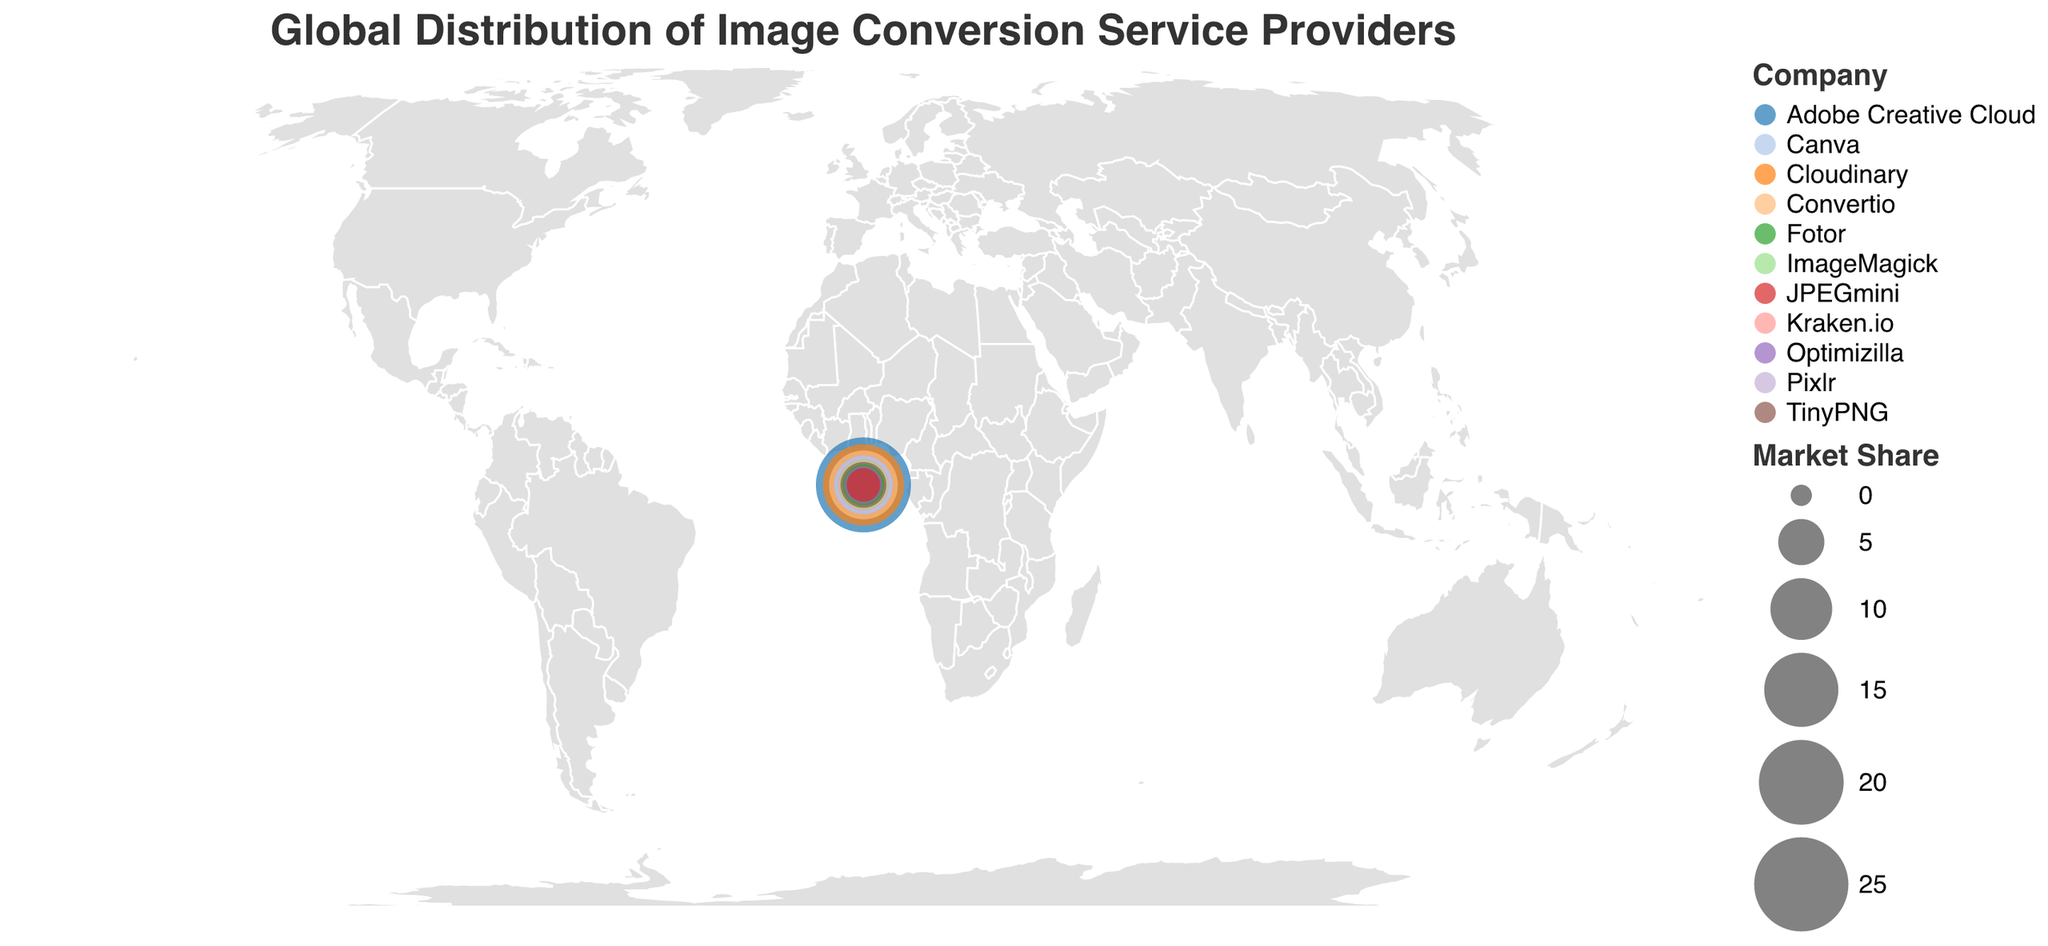What's the title of the figure? The title is typically located at the top of the figure and is displayed in a larger font size.
Answer: Global Distribution of Image Conversion Service Providers Which country has the highest market share in image conversion service providers? By examining the size of the circles, the country with the largest circle represents the highest market share.
Answer: United States What is the market share of Cloudinary in India? You can find the market share directly by locating India on the map and identifying the circle for Cloudinary.
Answer: 18.3 How many countries are represented in the figure? Count the number of unique countries listed in the dataset.
Answer: 11 Which companies are based in Germany and the United Kingdom, and what are their respective market shares? Locate the circles for Germany and the United Kingdom and identify the names and market share values of the companies.
Answer: Germany: Convertio (12.7), United Kingdom: Canva (8.6) What is the total market share of companies in the Americas (United States, Canada, Brazil)? Sum the market shares of companies in these countries.
Answer: 25.5 (United States) + 6.4 (Canada) + 2.9 (Brazil) = 34.8 Which two companies have the smallest market shares, and what are their values? Locate the smallest circles and identify the companies and their market share values.
Answer: JPEGmini (2.0) and Optimizilla (2.9) How does the market share of Adobe Creative Cloud compare to that of Pixlr? Compare the market share values of Adobe Creative Cloud in the United States and Pixlr in Japan.
Answer: Adobe Creative Cloud (25.5) > Pixlr (9.2) If you combine the market shares of Kraken.io and ImageMagick, what is the total market share? Add the market share values of Kraken.io and ImageMagick.
Answer: 6.4 (Kraken.io) + 5.8 (ImageMagick) = 12.2 Which continent has the most countries represented in this figure, and how many countries are there from that continent? Identify the continent of each country and count the number of countries per continent.
Answer: Asia (India, Japan, China, South Korea) with 4 countries 